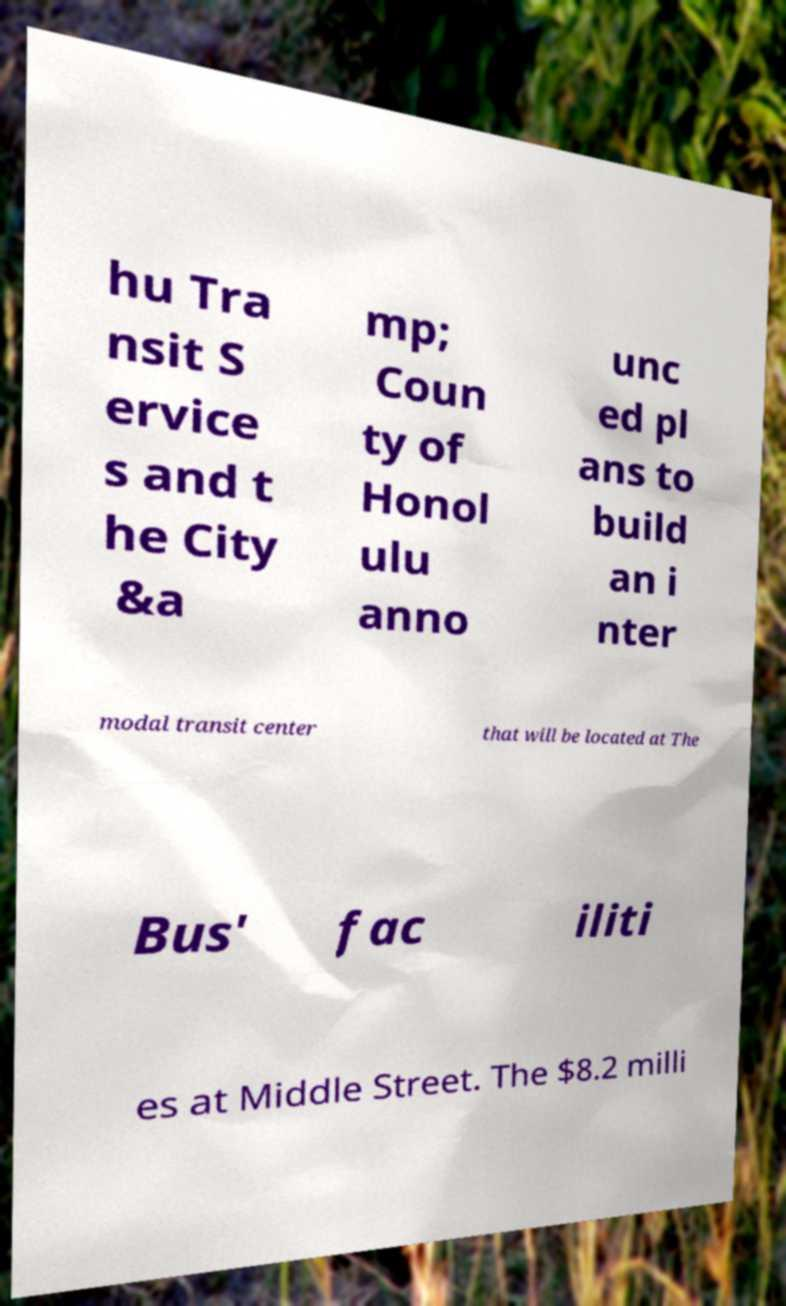What messages or text are displayed in this image? I need them in a readable, typed format. hu Tra nsit S ervice s and t he City &a mp; Coun ty of Honol ulu anno unc ed pl ans to build an i nter modal transit center that will be located at The Bus' fac iliti es at Middle Street. The $8.2 milli 